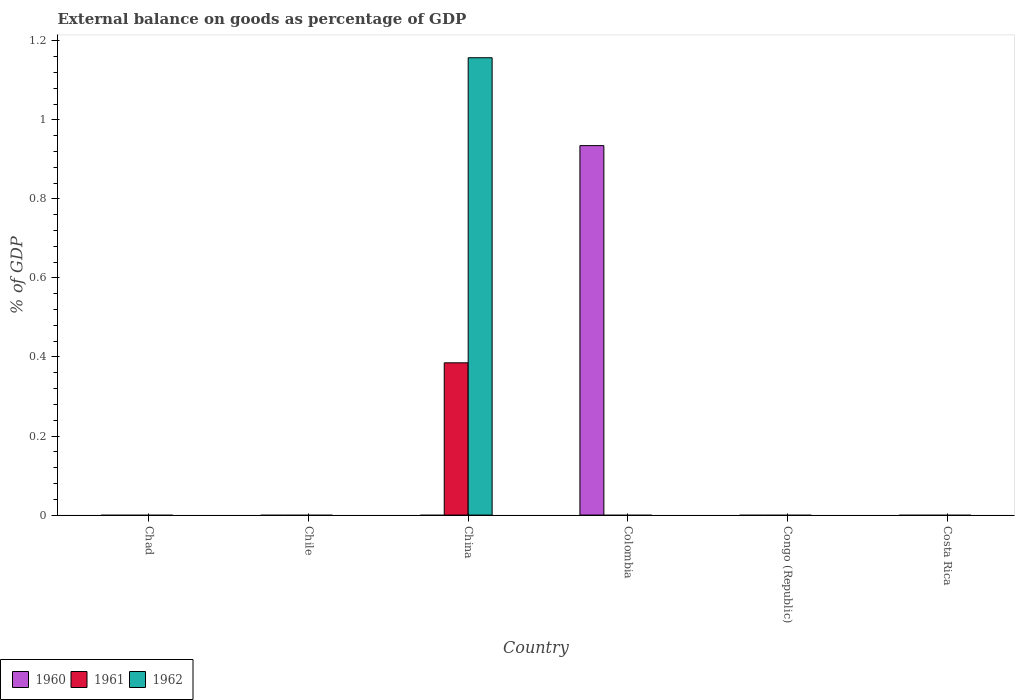How many different coloured bars are there?
Provide a succinct answer. 3. What is the label of the 3rd group of bars from the left?
Provide a short and direct response. China. What is the external balance on goods as percentage of GDP in 1962 in Costa Rica?
Offer a very short reply. 0. Across all countries, what is the maximum external balance on goods as percentage of GDP in 1962?
Your answer should be very brief. 1.16. Across all countries, what is the minimum external balance on goods as percentage of GDP in 1961?
Give a very brief answer. 0. In which country was the external balance on goods as percentage of GDP in 1961 maximum?
Offer a very short reply. China. What is the total external balance on goods as percentage of GDP in 1960 in the graph?
Ensure brevity in your answer.  0.93. What is the difference between the external balance on goods as percentage of GDP in 1960 in Colombia and the external balance on goods as percentage of GDP in 1961 in Chile?
Offer a terse response. 0.93. What is the average external balance on goods as percentage of GDP in 1961 per country?
Keep it short and to the point. 0.06. In how many countries, is the external balance on goods as percentage of GDP in 1962 greater than 0.36 %?
Your response must be concise. 1. What is the difference between the highest and the lowest external balance on goods as percentage of GDP in 1960?
Your response must be concise. 0.93. Is it the case that in every country, the sum of the external balance on goods as percentage of GDP in 1961 and external balance on goods as percentage of GDP in 1962 is greater than the external balance on goods as percentage of GDP in 1960?
Your answer should be very brief. No. How many bars are there?
Your answer should be compact. 3. What is the difference between two consecutive major ticks on the Y-axis?
Keep it short and to the point. 0.2. Does the graph contain any zero values?
Offer a very short reply. Yes. Does the graph contain grids?
Give a very brief answer. No. What is the title of the graph?
Provide a short and direct response. External balance on goods as percentage of GDP. What is the label or title of the X-axis?
Your response must be concise. Country. What is the label or title of the Y-axis?
Your answer should be compact. % of GDP. What is the % of GDP in 1961 in Chad?
Give a very brief answer. 0. What is the % of GDP of 1960 in Chile?
Keep it short and to the point. 0. What is the % of GDP in 1960 in China?
Make the answer very short. 0. What is the % of GDP in 1961 in China?
Provide a succinct answer. 0.39. What is the % of GDP in 1962 in China?
Give a very brief answer. 1.16. What is the % of GDP of 1960 in Colombia?
Offer a terse response. 0.93. What is the % of GDP in 1962 in Colombia?
Ensure brevity in your answer.  0. What is the % of GDP in 1961 in Congo (Republic)?
Your answer should be very brief. 0. What is the % of GDP in 1962 in Congo (Republic)?
Provide a short and direct response. 0. What is the % of GDP in 1961 in Costa Rica?
Your response must be concise. 0. Across all countries, what is the maximum % of GDP in 1960?
Make the answer very short. 0.93. Across all countries, what is the maximum % of GDP of 1961?
Your response must be concise. 0.39. Across all countries, what is the maximum % of GDP of 1962?
Provide a short and direct response. 1.16. Across all countries, what is the minimum % of GDP of 1960?
Give a very brief answer. 0. Across all countries, what is the minimum % of GDP of 1962?
Provide a succinct answer. 0. What is the total % of GDP in 1960 in the graph?
Provide a short and direct response. 0.93. What is the total % of GDP of 1961 in the graph?
Keep it short and to the point. 0.39. What is the total % of GDP of 1962 in the graph?
Offer a terse response. 1.16. What is the average % of GDP in 1960 per country?
Provide a succinct answer. 0.16. What is the average % of GDP in 1961 per country?
Make the answer very short. 0.06. What is the average % of GDP of 1962 per country?
Make the answer very short. 0.19. What is the difference between the % of GDP of 1961 and % of GDP of 1962 in China?
Your answer should be very brief. -0.77. What is the difference between the highest and the lowest % of GDP of 1960?
Offer a terse response. 0.93. What is the difference between the highest and the lowest % of GDP in 1961?
Your answer should be compact. 0.39. What is the difference between the highest and the lowest % of GDP in 1962?
Offer a very short reply. 1.16. 